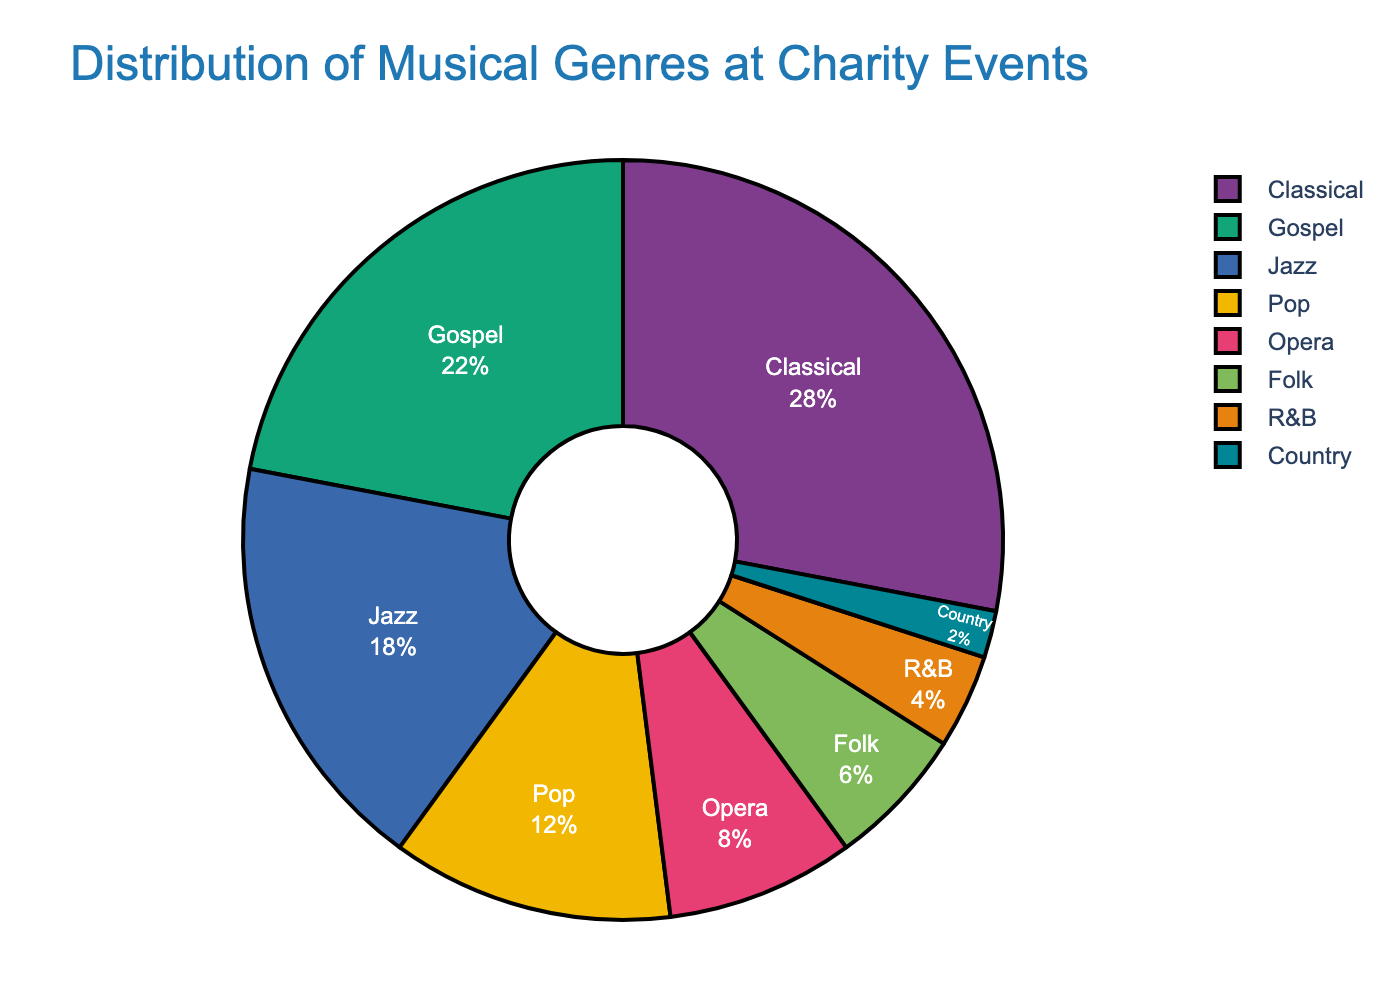What's the most performed genre by bass singers at charity events? The pie chart shows the distribution of musical genres. The largest segment of the pie chart is Classical with 28%.
Answer: Classical Which genre is performed more, Gospel or Jazz? By comparing the segments, Gospel is larger with 22%, whereas Jazz has 18%.
Answer: Gospel What is the combined percentage of Pop and Opera performances? The percentages for Pop and Opera are 12% and 8%, respectively. Adding them together gives 12 + 8 = 20%.
Answer: 20% How much more popular is Classical than Country among bass singers at charity events? Classical has 28% while Country has 2%. The difference is 28 - 2 = 26%.
Answer: 26% Which genres have a lower percentage than Jazz? Jazz has a percentage of 18%. The genres with lower percentages are Pop (12%), Opera (8%), Folk (6%), R&B (4%), and Country (2%).
Answer: Pop, Opera, Folk, R&B, Country What is the total percentage of Gospel, Jazz, and Folk performances? The percentages for Gospel, Jazz, and Folk are 22%, 18%, and 6%, respectively. Adding them together gives 22 + 18 + 6 = 46%.
Answer: 46% Is the percentage of Opera performances closer to the percentage of R&B or Gospel performances? Opera has 8%, R&B has 4%, and Gospel has 22%. The difference between Opera and R&B is 8 - 4 = 4%, while the difference between Opera and Gospel is 22 - 8 = 14%. Opera is closer to R&B.
Answer: R&B Which segment is the smallest in the pie chart? The smallest segment in the pie chart represents Country with 2%.
Answer: Country Are there more performances of Classical and Gospel combined than the rest? Classical and Gospel combined is 28 + 22 = 50%. The rest add up to 18 (Jazz) + 12 (Pop) + 8 (Opera) + 6 (Folk) + 4 (R&B) + 2 (Country) = 50%. They are equal.
Answer: No, they are equal 